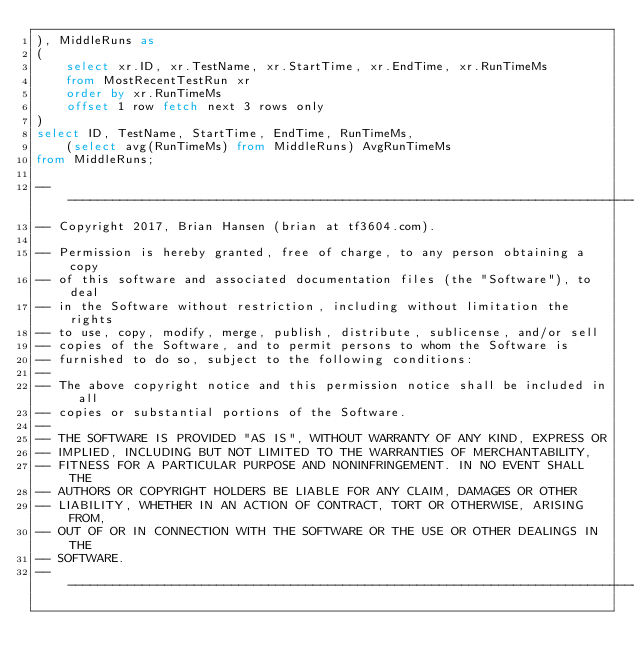Convert code to text. <code><loc_0><loc_0><loc_500><loc_500><_SQL_>), MiddleRuns as
(
	select xr.ID, xr.TestName, xr.StartTime, xr.EndTime, xr.RunTimeMs
	from MostRecentTestRun xr
	order by xr.RunTimeMs
	offset 1 row fetch next 3 rows only
)
select ID, TestName, StartTime, EndTime, RunTimeMs,
	(select avg(RunTimeMs) from MiddleRuns) AvgRunTimeMs
from MiddleRuns;

-----------------------------------------------------------------------------------------------------------------------
-- Copyright 2017, Brian Hansen (brian at tf3604.com).

-- Permission is hereby granted, free of charge, to any person obtaining a copy
-- of this software and associated documentation files (the "Software"), to deal
-- in the Software without restriction, including without limitation the rights
-- to use, copy, modify, merge, publish, distribute, sublicense, and/or sell
-- copies of the Software, and to permit persons to whom the Software is
-- furnished to do so, subject to the following conditions:
-- 
-- The above copyright notice and this permission notice shall be included in all
-- copies or substantial portions of the Software.
-- 
-- THE SOFTWARE IS PROVIDED "AS IS", WITHOUT WARRANTY OF ANY KIND, EXPRESS OR
-- IMPLIED, INCLUDING BUT NOT LIMITED TO THE WARRANTIES OF MERCHANTABILITY,
-- FITNESS FOR A PARTICULAR PURPOSE AND NONINFRINGEMENT. IN NO EVENT SHALL THE
-- AUTHORS OR COPYRIGHT HOLDERS BE LIABLE FOR ANY CLAIM, DAMAGES OR OTHER
-- LIABILITY, WHETHER IN AN ACTION OF CONTRACT, TORT OR OTHERWISE, ARISING FROM,
-- OUT OF OR IN CONNECTION WITH THE SOFTWARE OR THE USE OR OTHER DEALINGS IN THE
-- SOFTWARE.
-----------------------------------------------------------------------------------------------------------------------
</code> 